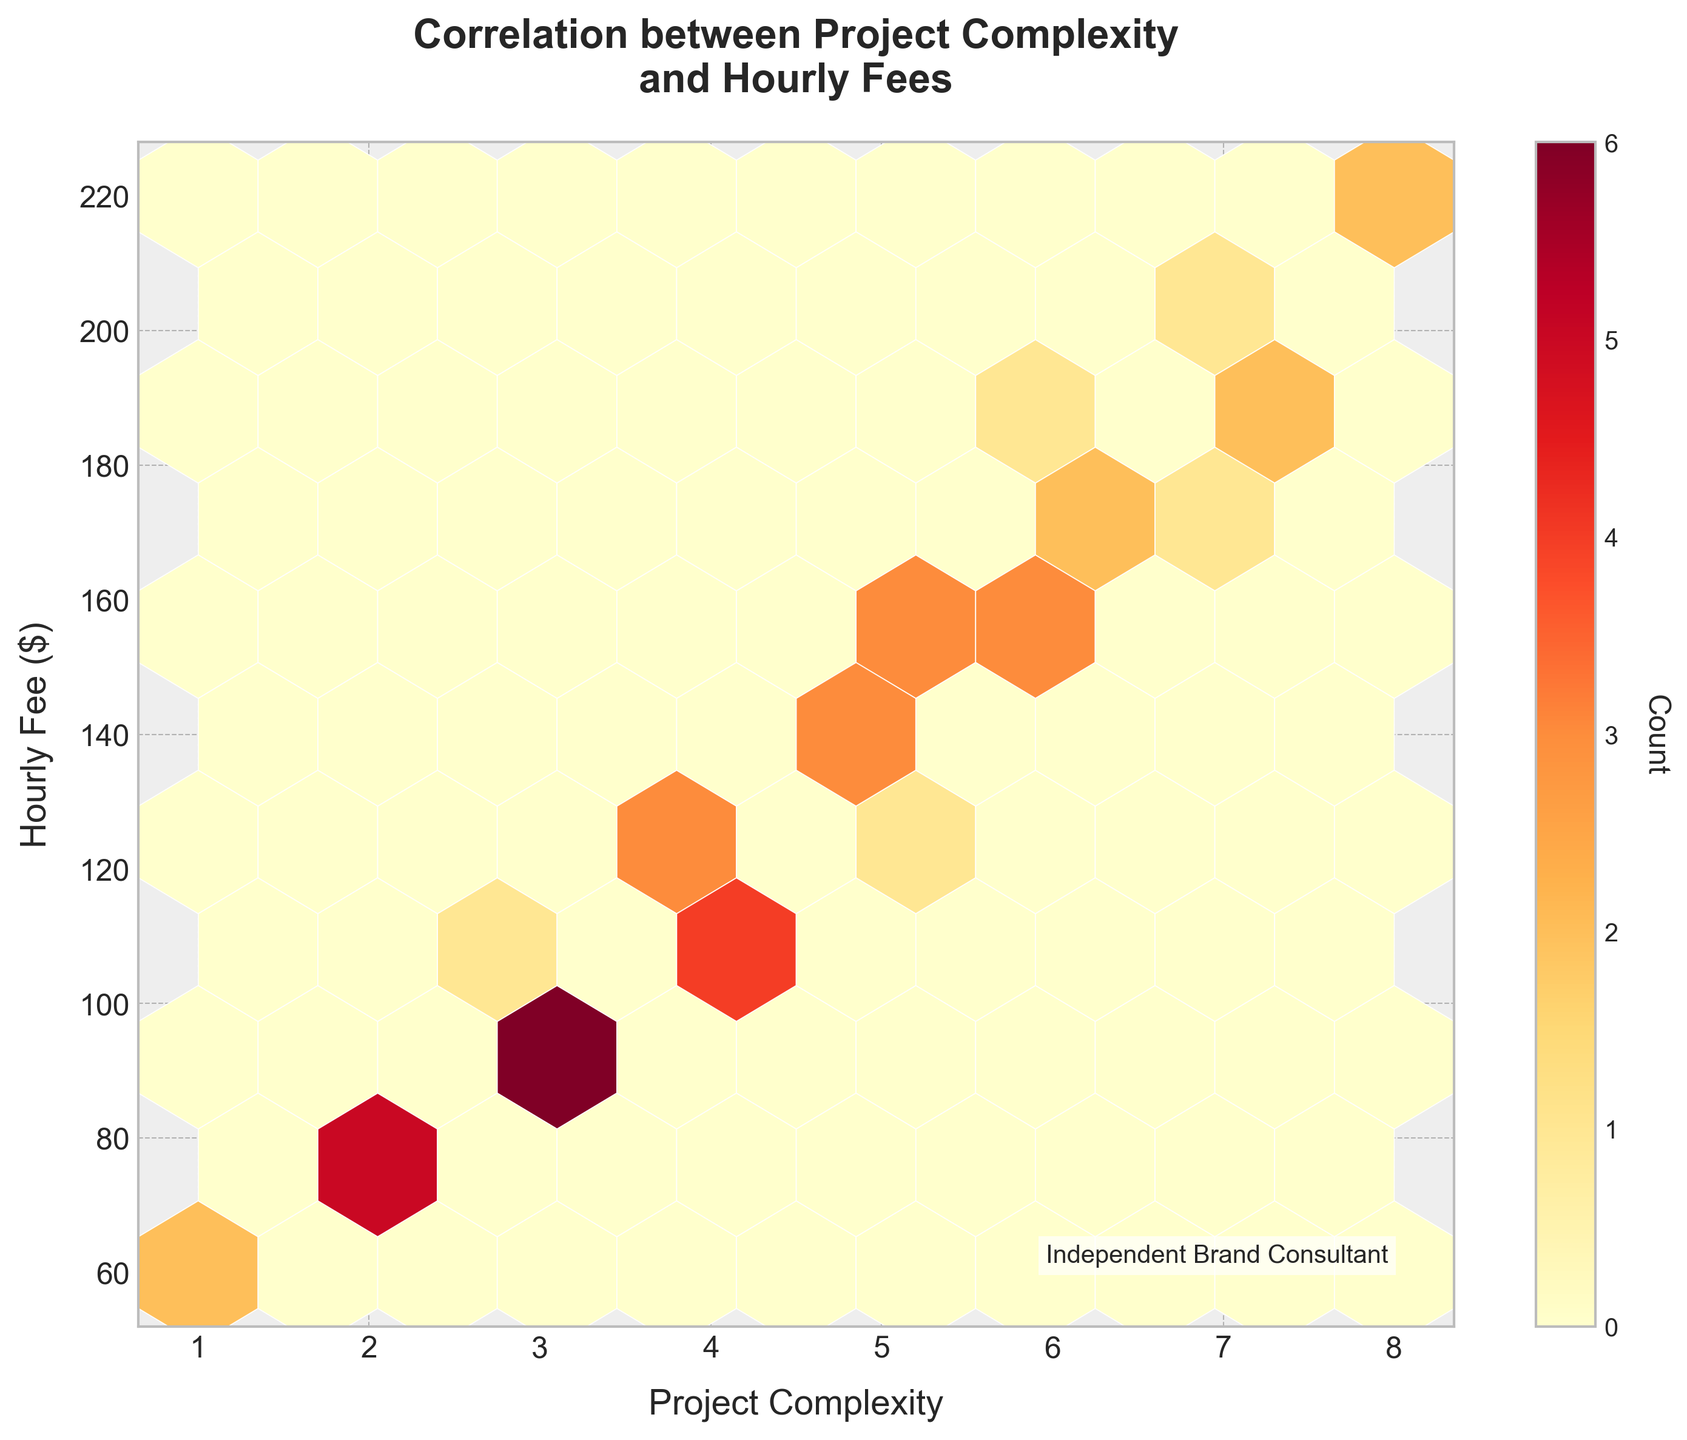What is the title of the plot? The title is usually at the top of a plot and it is written in larger, bold font. Looking at the figure, the title reads "Correlation between Project Complexity and Hourly Fees".
Answer: Correlation between Project Complexity and Hourly Fees What do the x-axis and y-axis represent? The x-axis label is usually below the horizontal axis, while the y-axis label is on the left side of the vertical axis. The x-axis represents "Project Complexity" and the y-axis represents "Hourly Fee ($)".
Answer: Project Complexity and Hourly Fee ($) Which axis shows the project complexity? The project complexity is indicated by the label on the x-axis or horizontal axis.
Answer: x-axis What is the highest value on the y-axis? The highest value on the y-axis can be seen at the top of the vertical axis. It is marked as $220.
Answer: 220 How many hexbins have the highest density? This can be inferred by looking at the color bar indicating the count. The densest hexbins are closest to the darkest color in the "YlOrRd" color map. Count the number of hexbins that show this color.
Answer: 1 Is there a general trend in the relationship between project complexity and hourly fee? To identify a trend, look for a pattern in the scatter of hexagons. Here, as project complexity increases, hourly fees seem to increase, showing a positive correlation.
Answer: Yes, there's a positive correlation Which project complexity level appears most frequently based on the hexbin plot? Look for the hexbin (hexagon) with the highest count, indicated by the darkest color in the color map and note its position on the x-axis. This occurs around a complexity level of 5.
Answer: 5 At a project complexity of 6, what is the approximate hourly fee range? Focus on the bin for project complexity 6 and observe the range on the y-axis for that bin. It shows that hourly fees generally range from $155 to $180.
Answer: $155 to $180 How does the count of lower hourly fees compare to higher hourly fees? Examine the color map and note the density of hexagons at the lower end of the y-axis compared to the higher end. The higher fees have hexagons covering a wider range with slightly lesser density.
Answer: Lower hourly fees have higher counts What do the colors in the hexbin plot indicate? The color map on the plot shows that darker colors represent higher counts of data points, while lighter colors indicate fewer data points within each hexbin.
Answer: Count (density) of data points 